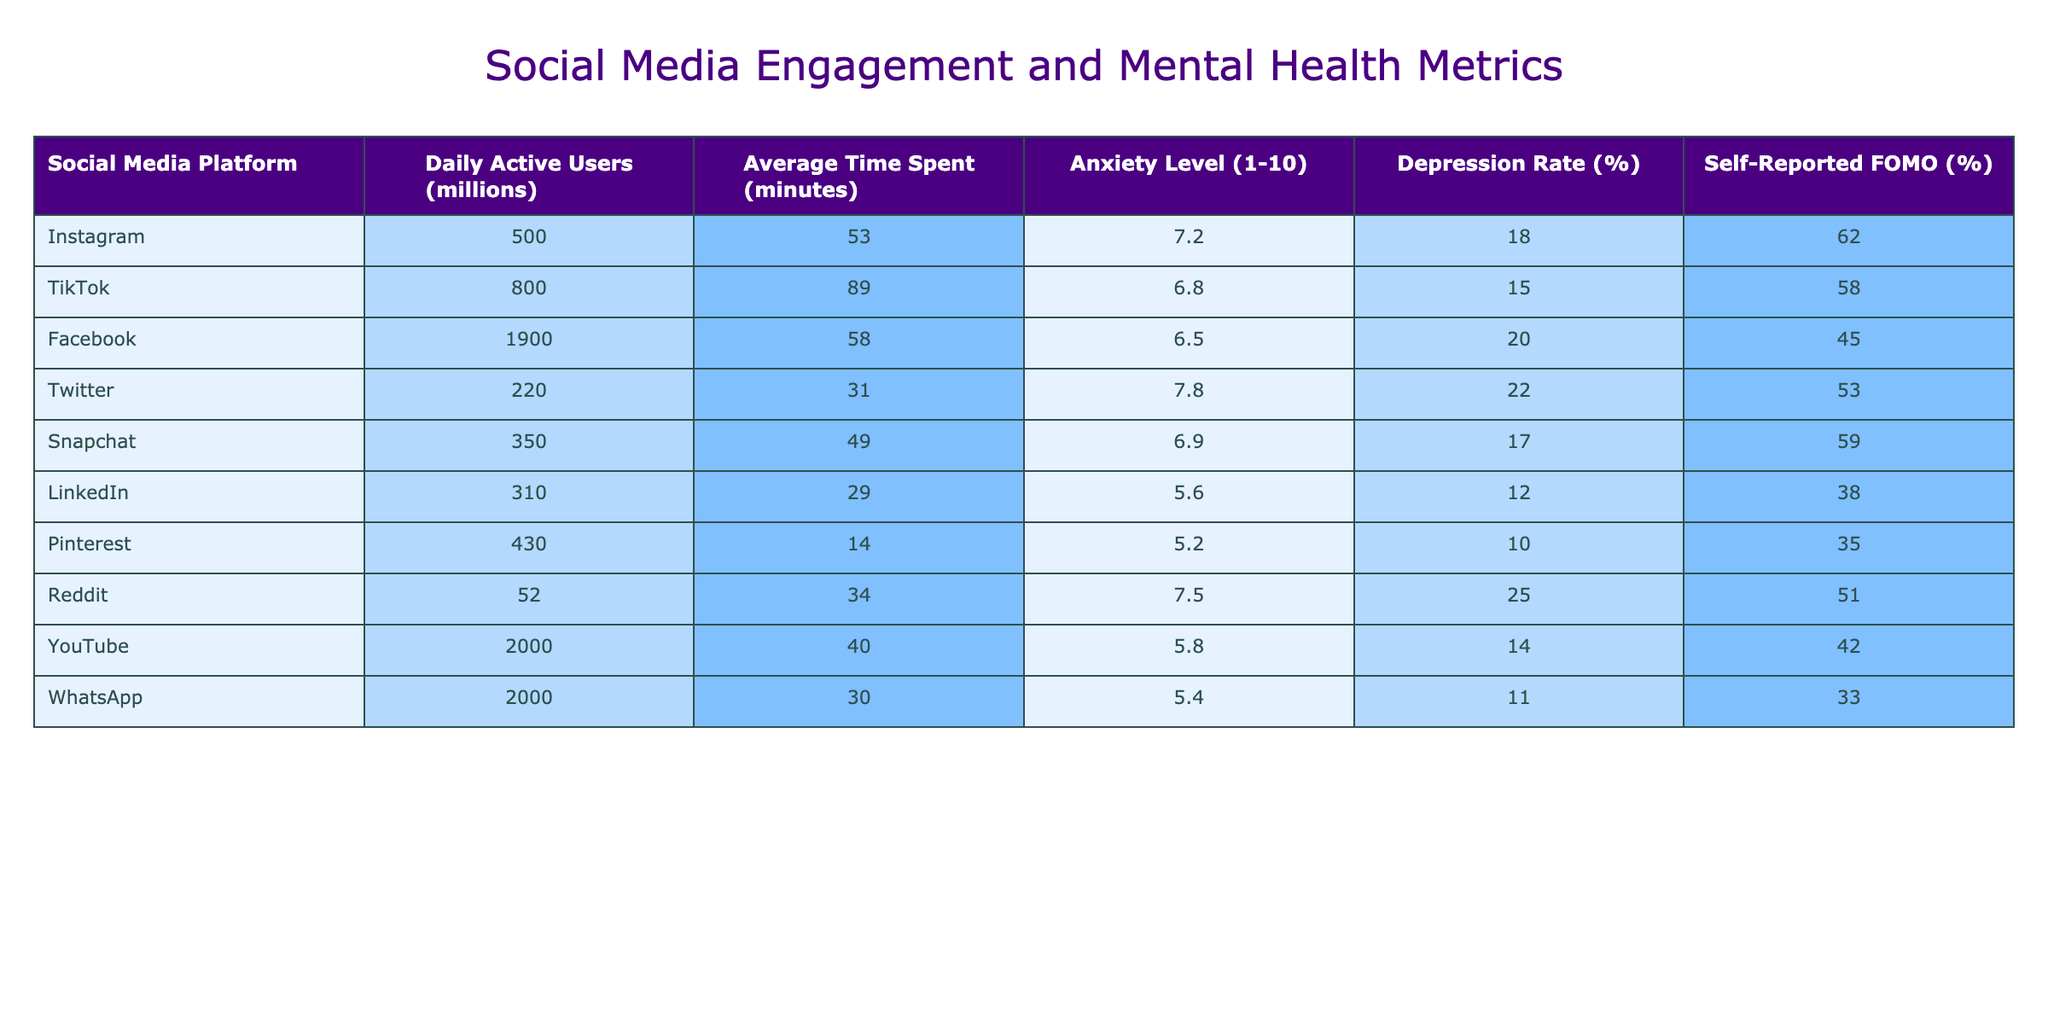What is the anxiety level of TikTok users? TikTok's anxiety level is directly listed in the table as 6.8.
Answer: 6.8 Which social media platform has the highest daily active users? The table shows Facebook with 1900 million daily active users as the highest value.
Answer: Facebook What is the average time spent on Instagram compared to Twitter? Instagram's average time spent is 53 minutes, while Twitter's is 31 minutes. The difference is 53 - 31 = 22 minutes.
Answer: 22 minutes Is the depression rate on Snapchat higher than on LinkedIn? Snapchat has a depression rate of 17%, while LinkedIn's rate is 12%. Since 17% is greater than 12%, the answer is yes.
Answer: Yes What is the total average time spent on Instagram and YouTube combined? The average time spent on Instagram is 53 minutes and on YouTube is 40 minutes. Adding these together gives 53 + 40 = 93 minutes.
Answer: 93 minutes Which platform has the lowest reported FOMO? By checking the FOMO percentages, Pinterest has the lowest at 35%.
Answer: Pinterest Calculate the median anxiety level from all platforms. The anxiety levels are: 7.2, 6.8, 6.5, 7.8, 6.9, 5.6, 5.2, 7.5, 5.8, 5.4. Sorting these gives: 5.2, 5.4, 5.6, 5.8, 6.5, 6.8, 6.9, 7.2, 7.5, 7.8. The median is the average of the 5th and 6th values: (6.5 + 6.8)/2 = 6.65.
Answer: 6.65 Which platform has the highest anxiety level and what is that level? By reviewing the anxiety levels, Twitter has the highest level at 7.8.
Answer: Twitter, 7.8 Are users on Pinterest more anxious than those on LinkedIn? Pinterest has an anxiety level of 5.2 and LinkedIn has 5.6. Since 5.2 is less than 5.6, the answer is no.
Answer: No Determine the average depression rate across all platforms. The depression rates are: 18, 15, 20, 22, 17, 12, 10, 25, 14, 11. The total is 18 + 15 + 20 + 22 + 17 + 12 + 10 + 25 + 14 + 11 =  154. There are 10 platforms, so the average is 154 / 10 = 15.4%.
Answer: 15.4% 